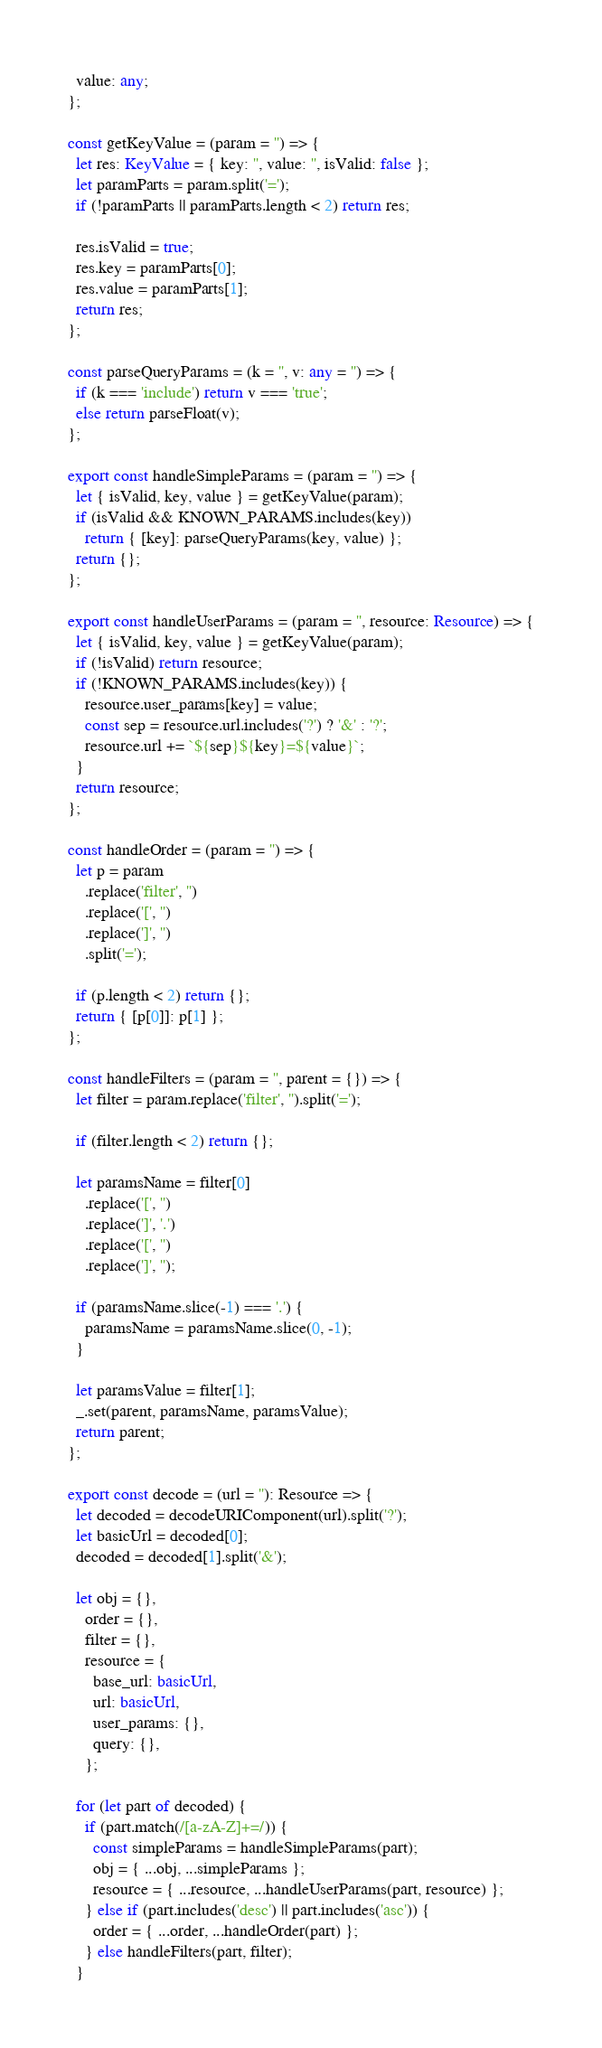<code> <loc_0><loc_0><loc_500><loc_500><_TypeScript_>  value: any;
};

const getKeyValue = (param = '') => {
  let res: KeyValue = { key: '', value: '', isValid: false };
  let paramParts = param.split('=');
  if (!paramParts || paramParts.length < 2) return res;

  res.isValid = true;
  res.key = paramParts[0];
  res.value = paramParts[1];
  return res;
};

const parseQueryParams = (k = '', v: any = '') => {
  if (k === 'include') return v === 'true';
  else return parseFloat(v);
};

export const handleSimpleParams = (param = '') => {
  let { isValid, key, value } = getKeyValue(param);
  if (isValid && KNOWN_PARAMS.includes(key))
    return { [key]: parseQueryParams(key, value) };
  return {};
};

export const handleUserParams = (param = '', resource: Resource) => {
  let { isValid, key, value } = getKeyValue(param);
  if (!isValid) return resource;
  if (!KNOWN_PARAMS.includes(key)) {
    resource.user_params[key] = value;
    const sep = resource.url.includes('?') ? '&' : '?';
    resource.url += `${sep}${key}=${value}`;
  }
  return resource;
};

const handleOrder = (param = '') => {
  let p = param
    .replace('filter', '')
    .replace('[', '')
    .replace(']', '')
    .split('=');

  if (p.length < 2) return {};
  return { [p[0]]: p[1] };
};

const handleFilters = (param = '', parent = {}) => {
  let filter = param.replace('filter', '').split('=');

  if (filter.length < 2) return {};

  let paramsName = filter[0]
    .replace('[', '')
    .replace(']', '.')
    .replace('[', '')
    .replace(']', '');

  if (paramsName.slice(-1) === '.') {
    paramsName = paramsName.slice(0, -1);
  }

  let paramsValue = filter[1];
  _.set(parent, paramsName, paramsValue);
  return parent;
};

export const decode = (url = ''): Resource => {
  let decoded = decodeURIComponent(url).split('?');
  let basicUrl = decoded[0];
  decoded = decoded[1].split('&');

  let obj = {},
    order = {},
    filter = {},
    resource = {
      base_url: basicUrl,
      url: basicUrl,
      user_params: {},
      query: {},
    };

  for (let part of decoded) {
    if (part.match(/[a-zA-Z]+=/)) {
      const simpleParams = handleSimpleParams(part);
      obj = { ...obj, ...simpleParams };
      resource = { ...resource, ...handleUserParams(part, resource) };
    } else if (part.includes('desc') || part.includes('asc')) {
      order = { ...order, ...handleOrder(part) };
    } else handleFilters(part, filter);
  }
</code> 